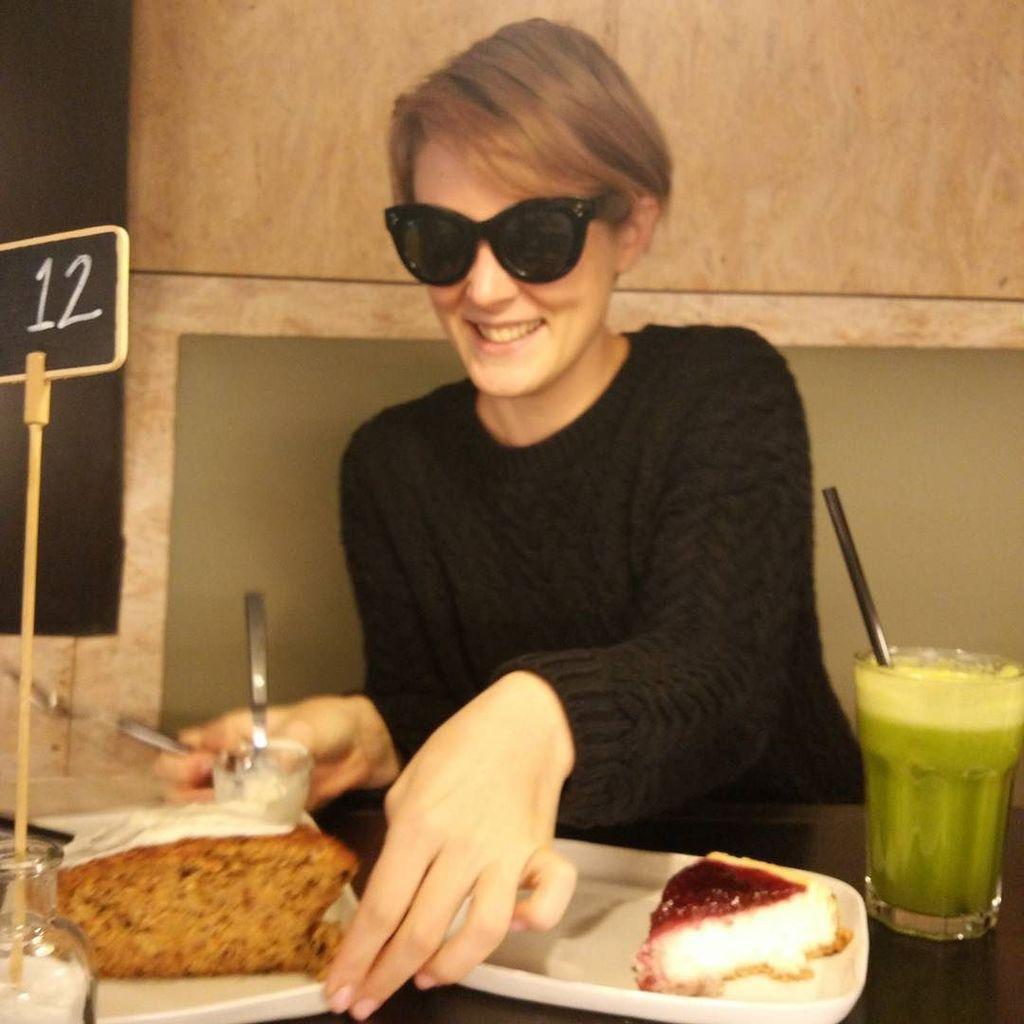What is the lady in the image wearing on her face? The lady is wearing sunglasses. What color is the top the lady is wearing? The lady is wearing a black top. What is the lady doing in the image? The lady is sitting. What is in front of the lady? There is a table in front of the lady. What types of food can be seen on the table? There are foods on the table, but the specific types are not mentioned. What is being served in the glasses on the table? There are drinks in glasses on the table. What other items can be seen on the table? There are other unspecified items on the table. What type of vegetable is being traded between the lady and her neighbor in the image? There is no indication of any vegetable trade or neighbor in the image. 